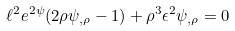Convert formula to latex. <formula><loc_0><loc_0><loc_500><loc_500>\ell ^ { 2 } e ^ { 2 \psi } ( 2 \rho \psi _ { , \rho } - 1 ) + \rho ^ { 3 } \epsilon ^ { 2 } \psi _ { , \rho } = 0</formula> 